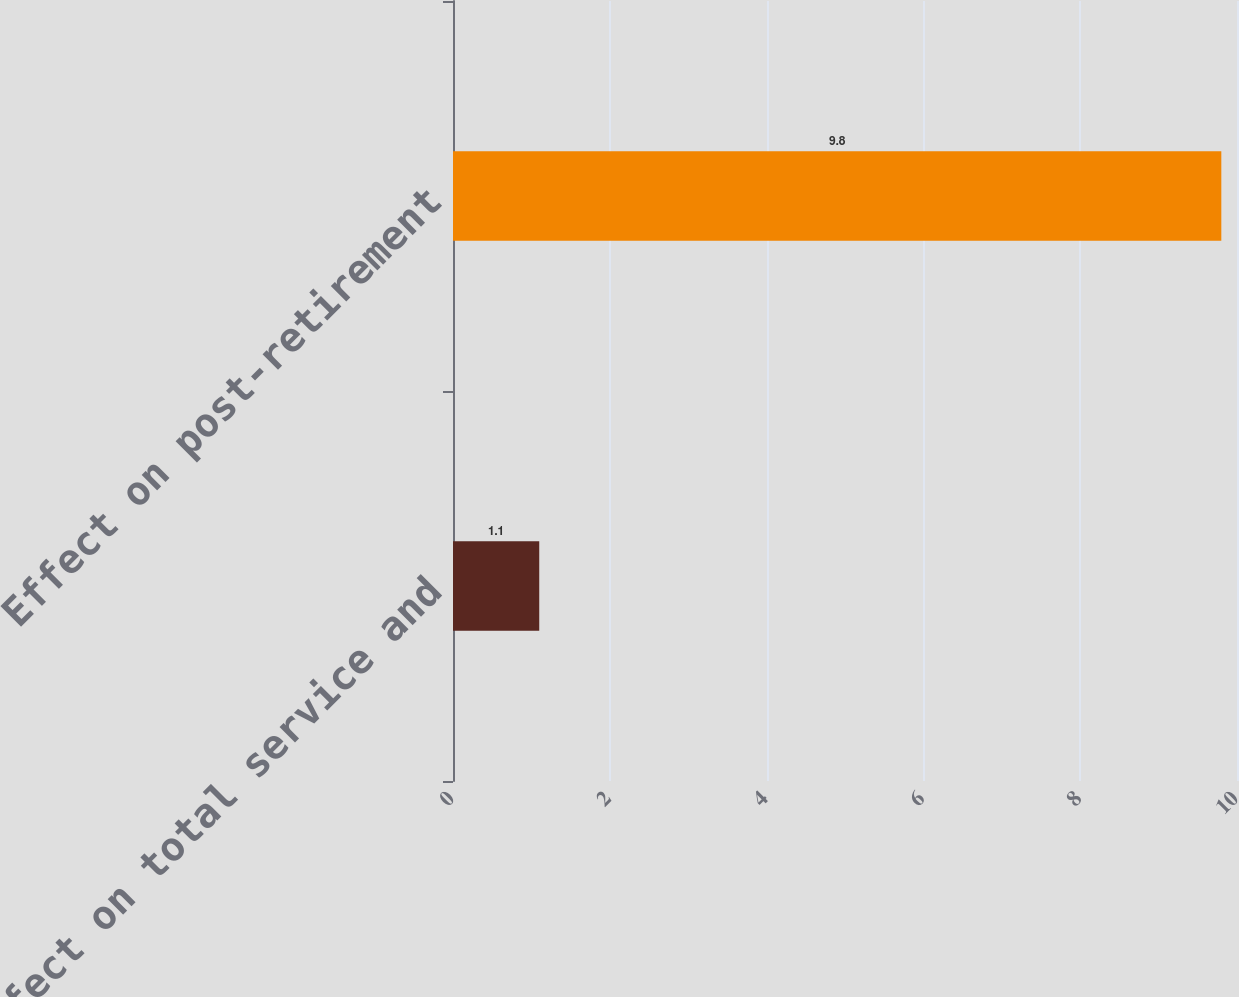Convert chart. <chart><loc_0><loc_0><loc_500><loc_500><bar_chart><fcel>Effect on total service and<fcel>Effect on post-retirement<nl><fcel>1.1<fcel>9.8<nl></chart> 